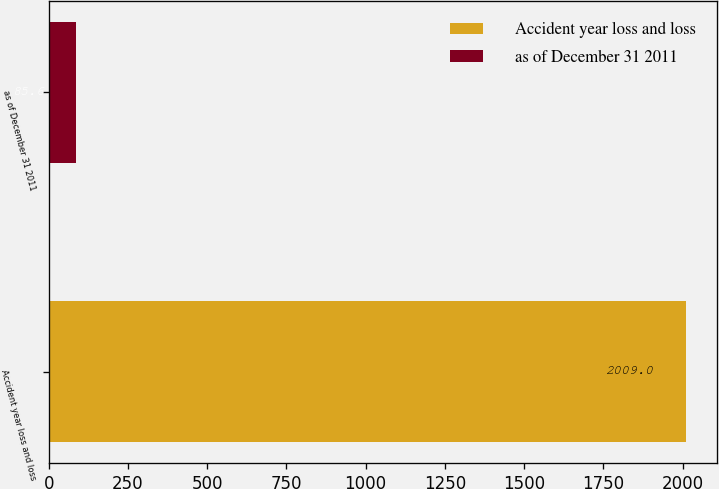<chart> <loc_0><loc_0><loc_500><loc_500><bar_chart><fcel>Accident year loss and loss<fcel>as of December 31 2011<nl><fcel>2009<fcel>85.6<nl></chart> 